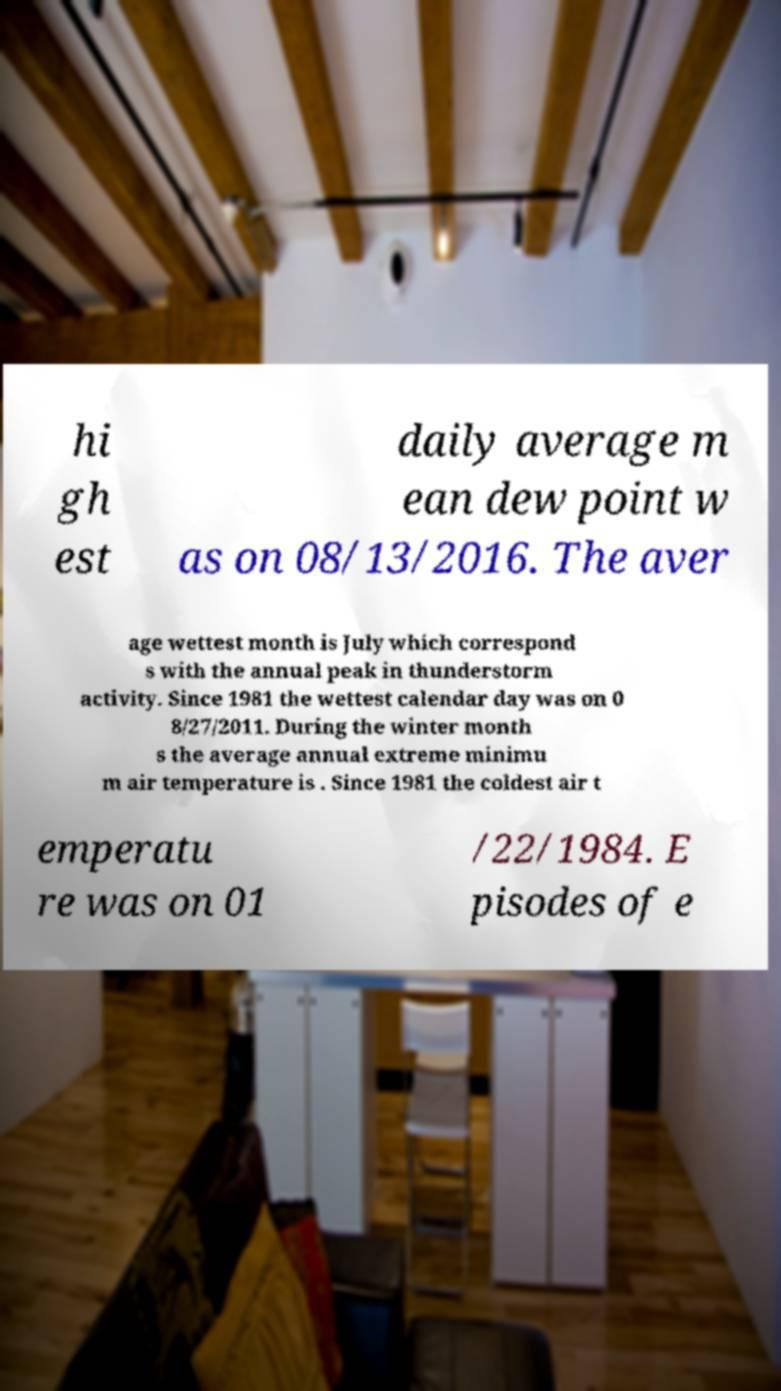I need the written content from this picture converted into text. Can you do that? hi gh est daily average m ean dew point w as on 08/13/2016. The aver age wettest month is July which correspond s with the annual peak in thunderstorm activity. Since 1981 the wettest calendar day was on 0 8/27/2011. During the winter month s the average annual extreme minimu m air temperature is . Since 1981 the coldest air t emperatu re was on 01 /22/1984. E pisodes of e 